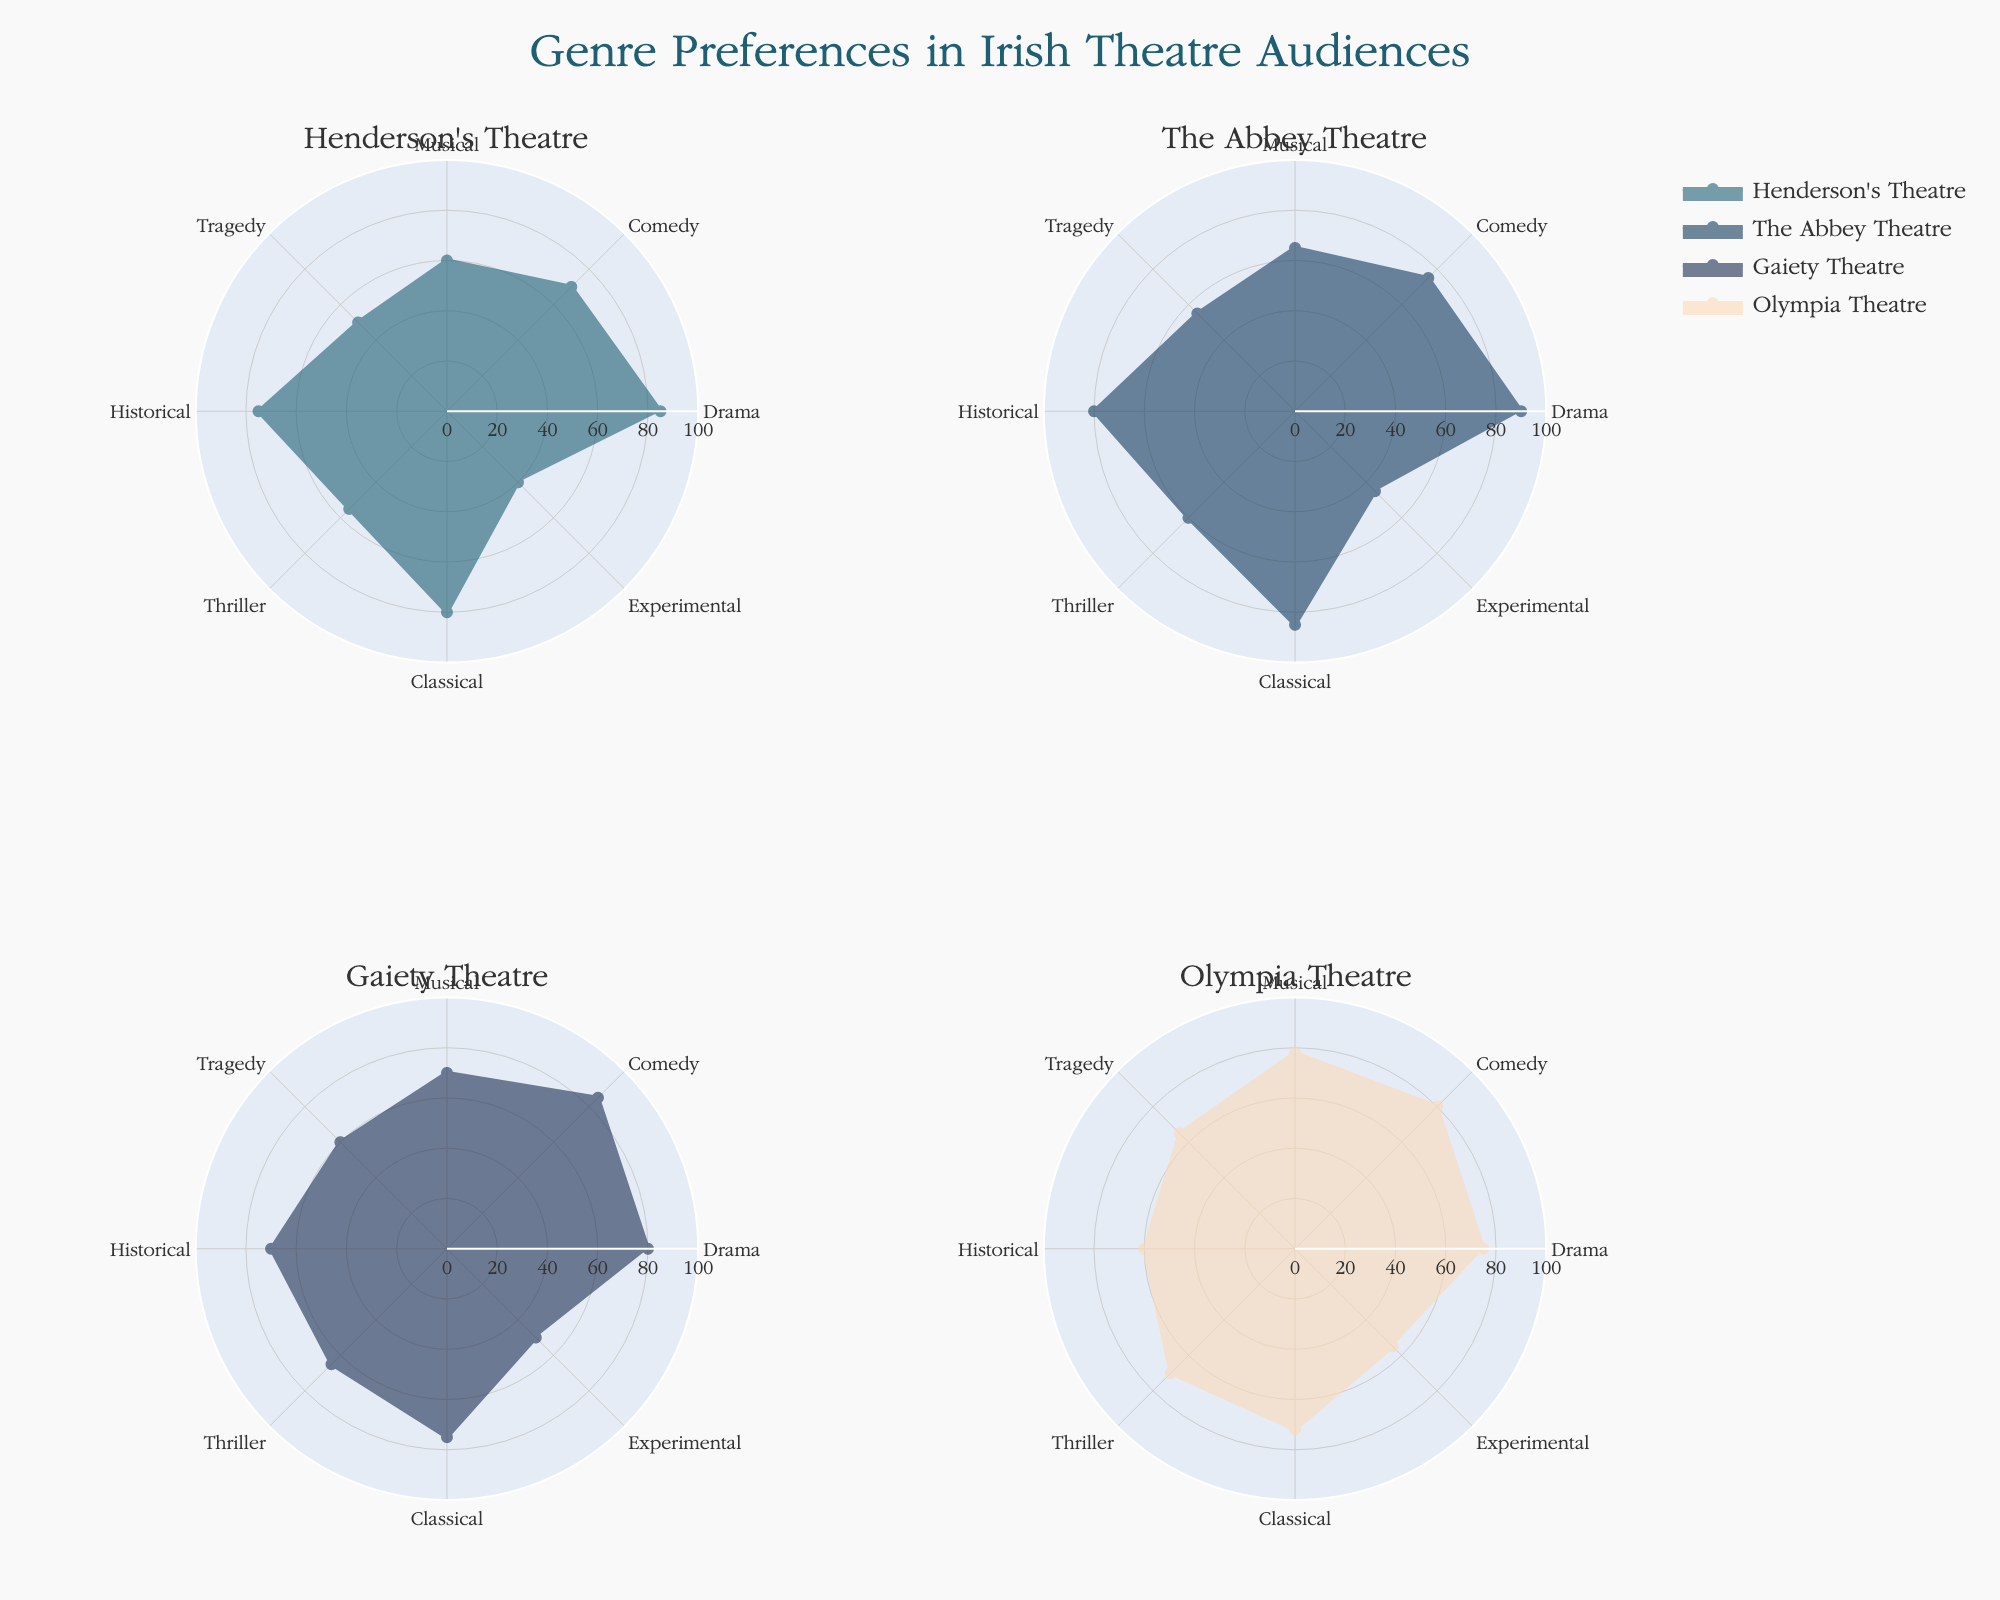What is the highest preference score for Drama? The highest preference score for Drama can be found by looking at the Drama segment on each subplot and identifying the highest value among Henderson's Theatre, The Abbey Theatre, Gaiety Theatre, and Olympia Theatre. The highest score is 90 from The Abbey Theatre.
Answer: 90 Which theatre has the lowest preference score for Experimental? To find the lowest preference score for Experimental, check the Experimental segment in each subplot and identify the smallest value. The lowest score is 40 from Henderson's Theatre.
Answer: 40 What is the overall ranking of genres in Henderson's Theatre from highest to lowest preference? By observing Henderson's Theatre radar chart, rank the genres based on their scores: Drama (85), Classical (80), Historical (75), Comedy (70), Musical (60), Thriller (55), Tragedy (50), Experimental (40).
Answer: Drama, Classical, Historical, Comedy, Musical, Thriller, Tragedy, Experimental How much higher is the preference score of Comedy in Gaiety Theatre compared to Historical in Olympia Theatre? The preference score for Comedy in Gaiety Theatre is 85, and Historical in Olympia Theatre is 60. Subtract the two values: 85 - 60 = 25.
Answer: 25 Which theatre has the most balanced preferences across all genres? A theatre is most balanced if the differences between preference scores across genres are the smallest. By inspecting the radar charts visually, Gaiety Theatre has less variance among scores, indicating it has the most balanced preferences.
Answer: Gaiety Theatre What is the combined preference score for Thriller and Classical genres in Olympia Theatre? Adding the two scores from Olympia Theatre's radar chart, Thriller (70) and Classical (72), gives 70 + 72 = 142.
Answer: 142 Which genre has the lowest average preference score across all theatres? Calculate the average for each genre by summing its scores from all theatres and dividing by the number of theatres. Experimental averages to (40+45+50+55)/4 = 47.5.
Answer: Experimental How many genres does The Abbey Theatre have a score of 85 or higher? Check each segment for The Abbey Theatre radar chart and count the genres with scores of 85 or higher. They are Drama (90) and Classical (85), making 2 genres.
Answer: 2 Between Musical and Tragedy, which genre has a higher average preference score across all theatres? Calculate the average scores for both genres: Musical average = (60+65+70+78)/4 = 68.25, and Tragedy average = (50+55+60+65)/4 = 57.5. Therefore, Musical has a higher average score.
Answer: Musical 